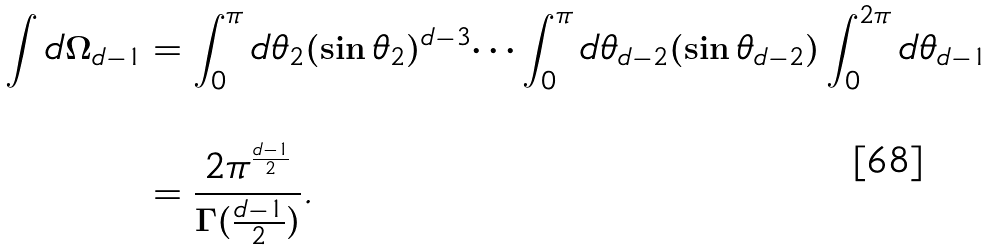Convert formula to latex. <formula><loc_0><loc_0><loc_500><loc_500>\int d \Omega _ { d - 1 } & = \int _ { 0 } ^ { \pi } d \theta _ { 2 } ( \sin \theta _ { 2 } ) ^ { d - 3 } \dots \int _ { 0 } ^ { \pi } d \theta _ { d - 2 } ( \sin \theta _ { d - 2 } ) \int _ { 0 } ^ { 2 \pi } d \theta _ { d - 1 } \\ \\ & = \frac { 2 \pi ^ { \frac { d - 1 } { 2 } } } { \Gamma ( \frac { d - 1 } { 2 } ) } .</formula> 